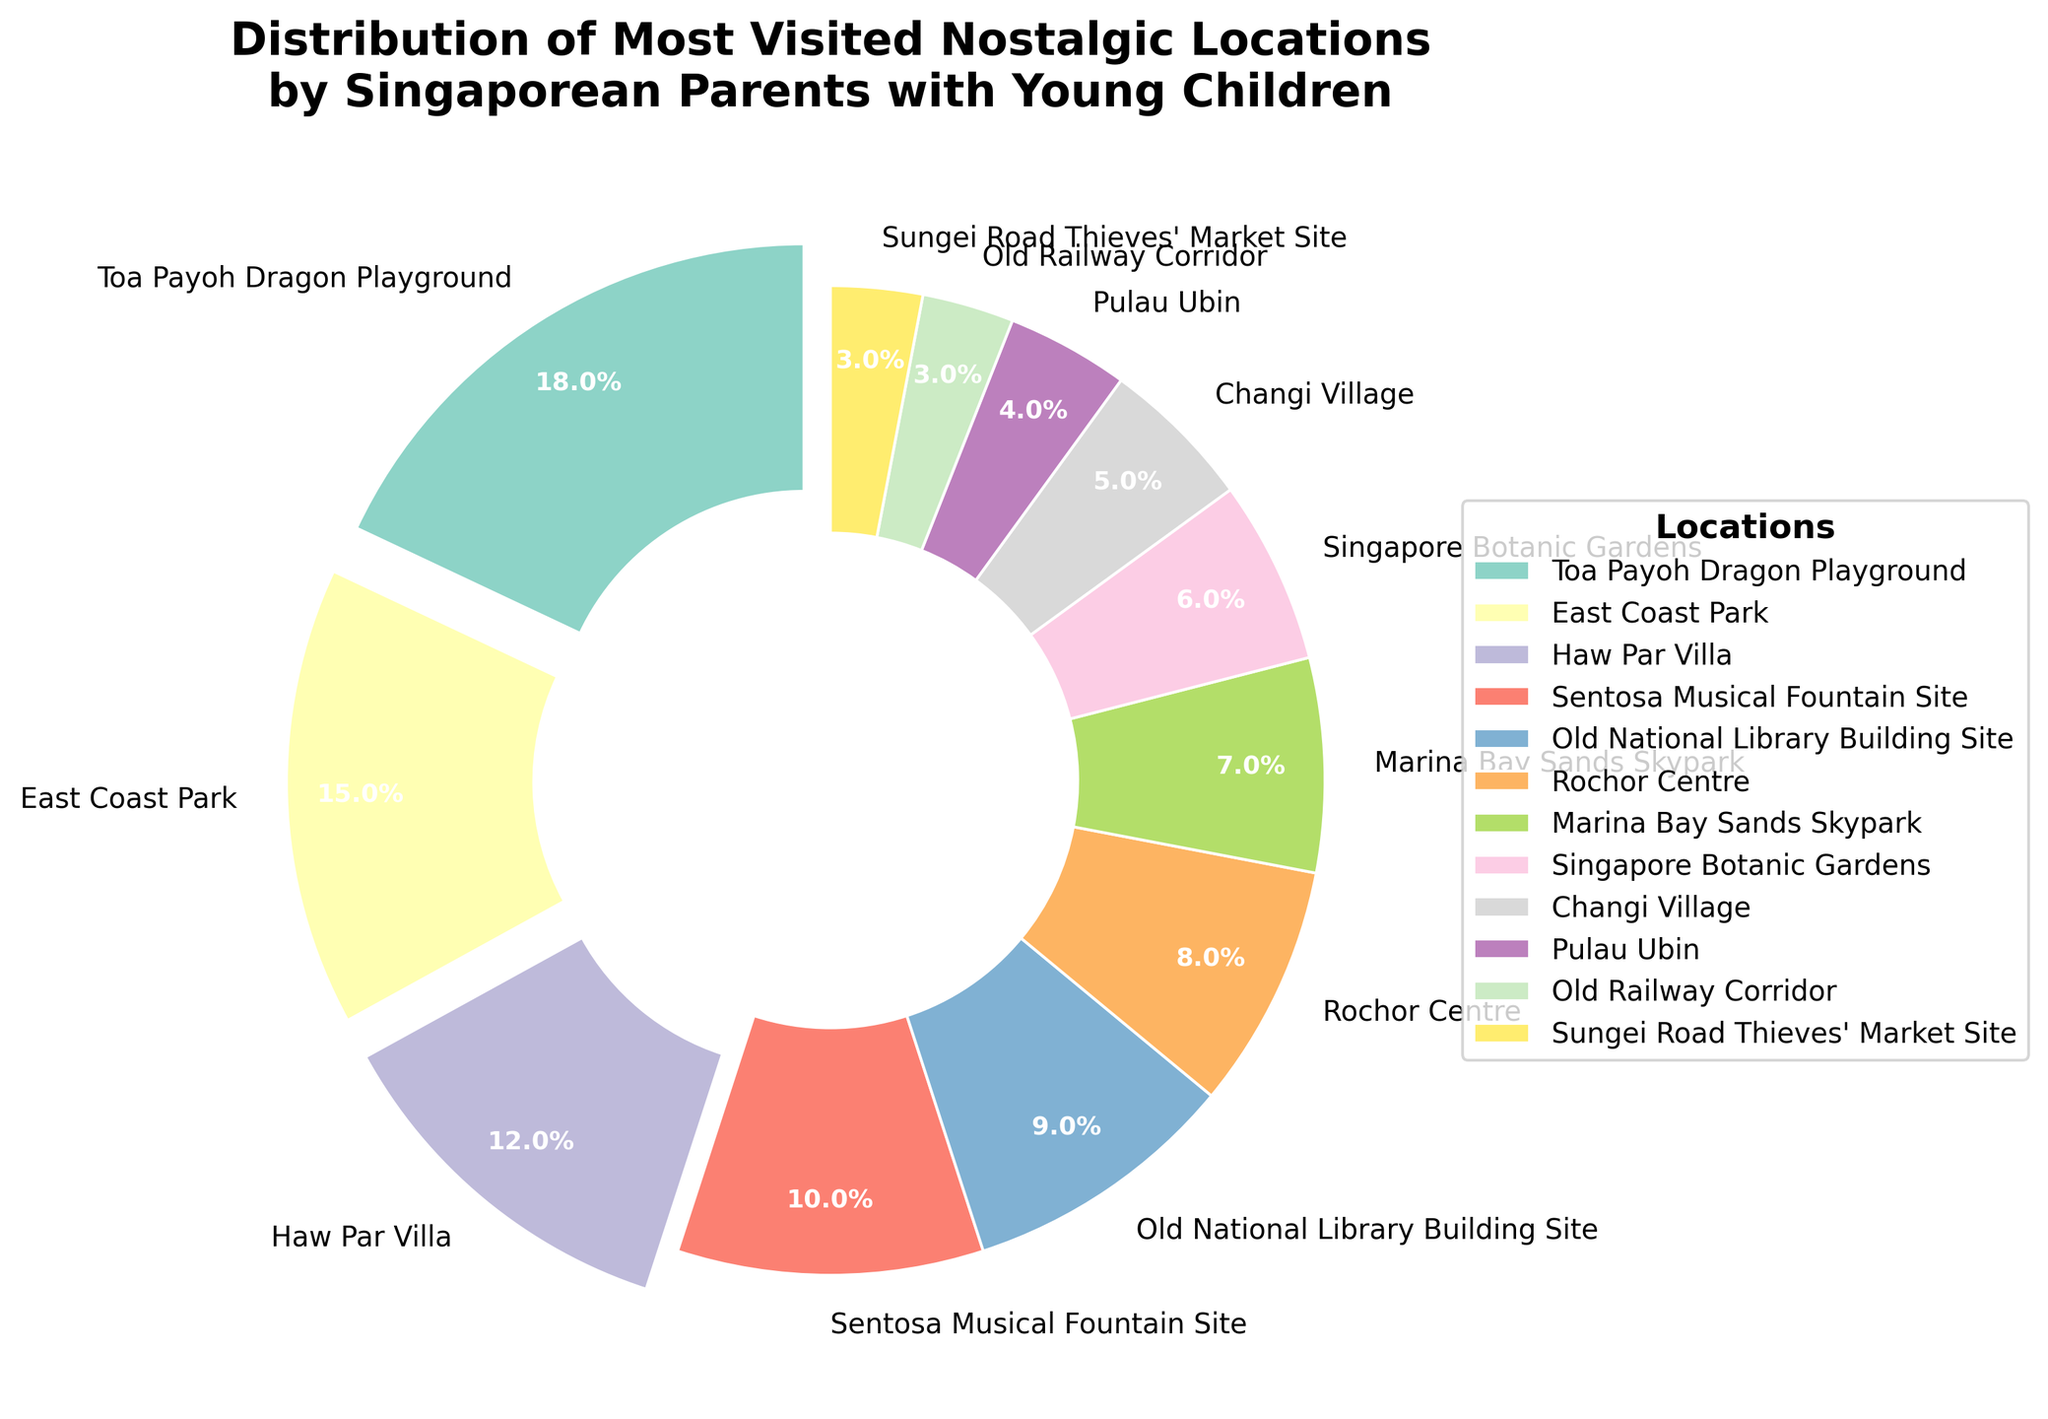What percentage of parents visited Toa Payoh Dragon Playground? Locate Toa Payoh Dragon Playground in the pie chart and refer to the percentage labeled on it.
Answer: 18% Which location is the least visited among the nostalgic places listed? Find the location with the smallest percentage in the pie chart.
Answer: Old Railway Corridor How many total percentage points do East Coast Park and Changi Village represent combined? Add the percentages for East Coast Park (15) and Changi Village (5). 15 + 5 = 20
Answer: 20% Is the percentage of visits to the Marina Bay Sands Skypark greater than that to the Singapore Botanic Gardens? Compare the two percentages: Marina Bay Sands Skypark (7%) and the Singapore Botanic Gardens (6%). 7% is greater than 6%.
Answer: Yes Which locations have percentages that are greater than 10%? Identify all locations in the pie chart with percentages greater than 10%: Toa Payoh Dragon Playground (18%), East Coast Park (15%), Haw Par Villa (12%).
Answer: Toa Payoh Dragon Playground, East Coast Park, Haw Par Villa How much more popular is the Toa Payoh Dragon Playground compared to Rochor Centre? Subtract the percentage for Rochor Centre (8%) from the percentage for Toa Payoh Dragon Playground (18%). 18 - 8 = 10
Answer: 10% Among the listed locations, which one has a wedge colored blue? Locate the blue-colored wedge in the pie chart and note its label.
Answer: East Coast Park Which location shares the exact same percentage as Sungei Road Thieves' Market Site? Find the percentage for Sungei Road Thieves' Market Site (3%) and locate any other location with the same value.
Answer: Old Railway Corridor What is the average percentage of visits for Pulau Ubin, Singapore Botanic Gardens, and Marina Bay Sands Skypark? Sum the percentages for Pulau Ubin (4%), Singapore Botanic Gardens (6%), and Marina Bay Sands Skypark (7%) and divide by 3. (4 + 6 + 7) / 3 = 17 / 3 ≈ 5.67
Answer: 5.67% How many locations have a wedge with a significant 'explode' effect? Identify locations with noticeable separation ('explode' effect). These are ones with percentages greater than 10%: Toa Payoh Dragon Playground, East Coast Park, Haw Par Villa.
Answer: 3 